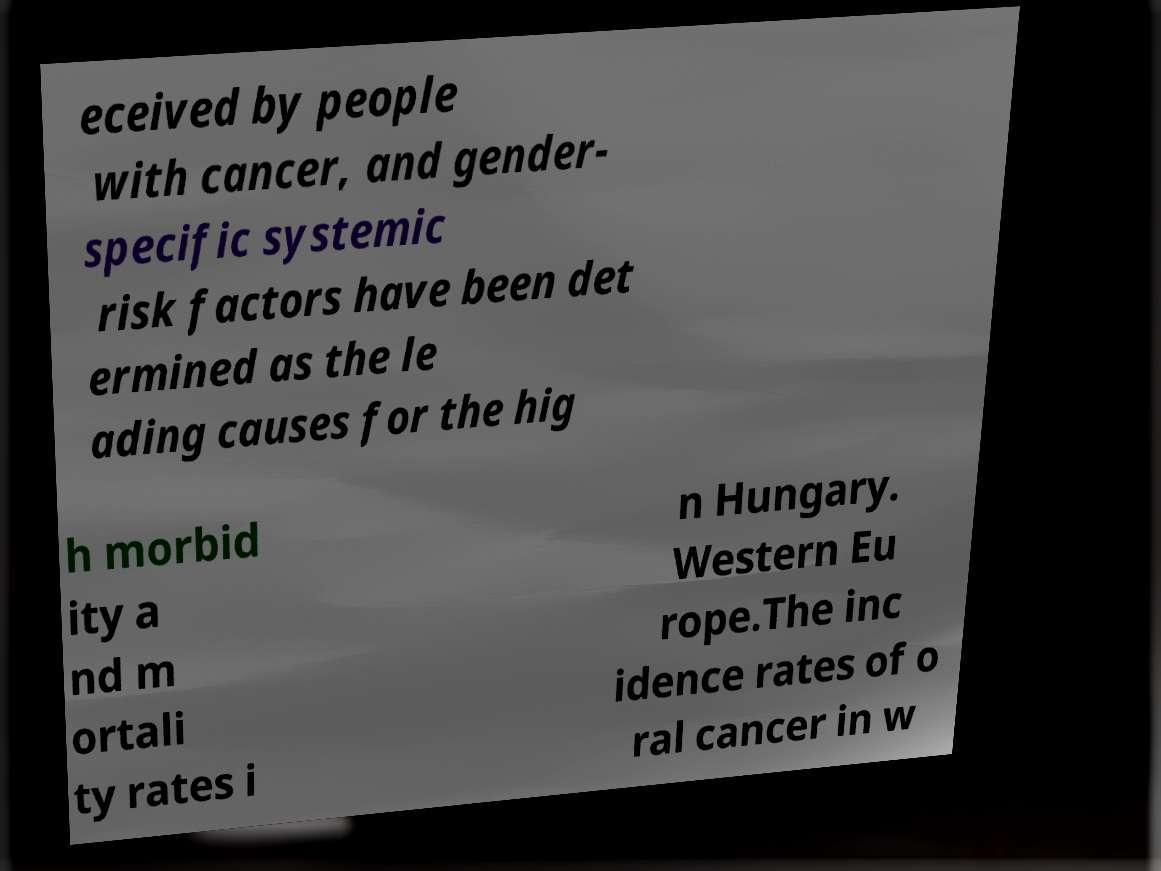Please read and relay the text visible in this image. What does it say? eceived by people with cancer, and gender- specific systemic risk factors have been det ermined as the le ading causes for the hig h morbid ity a nd m ortali ty rates i n Hungary. Western Eu rope.The inc idence rates of o ral cancer in w 